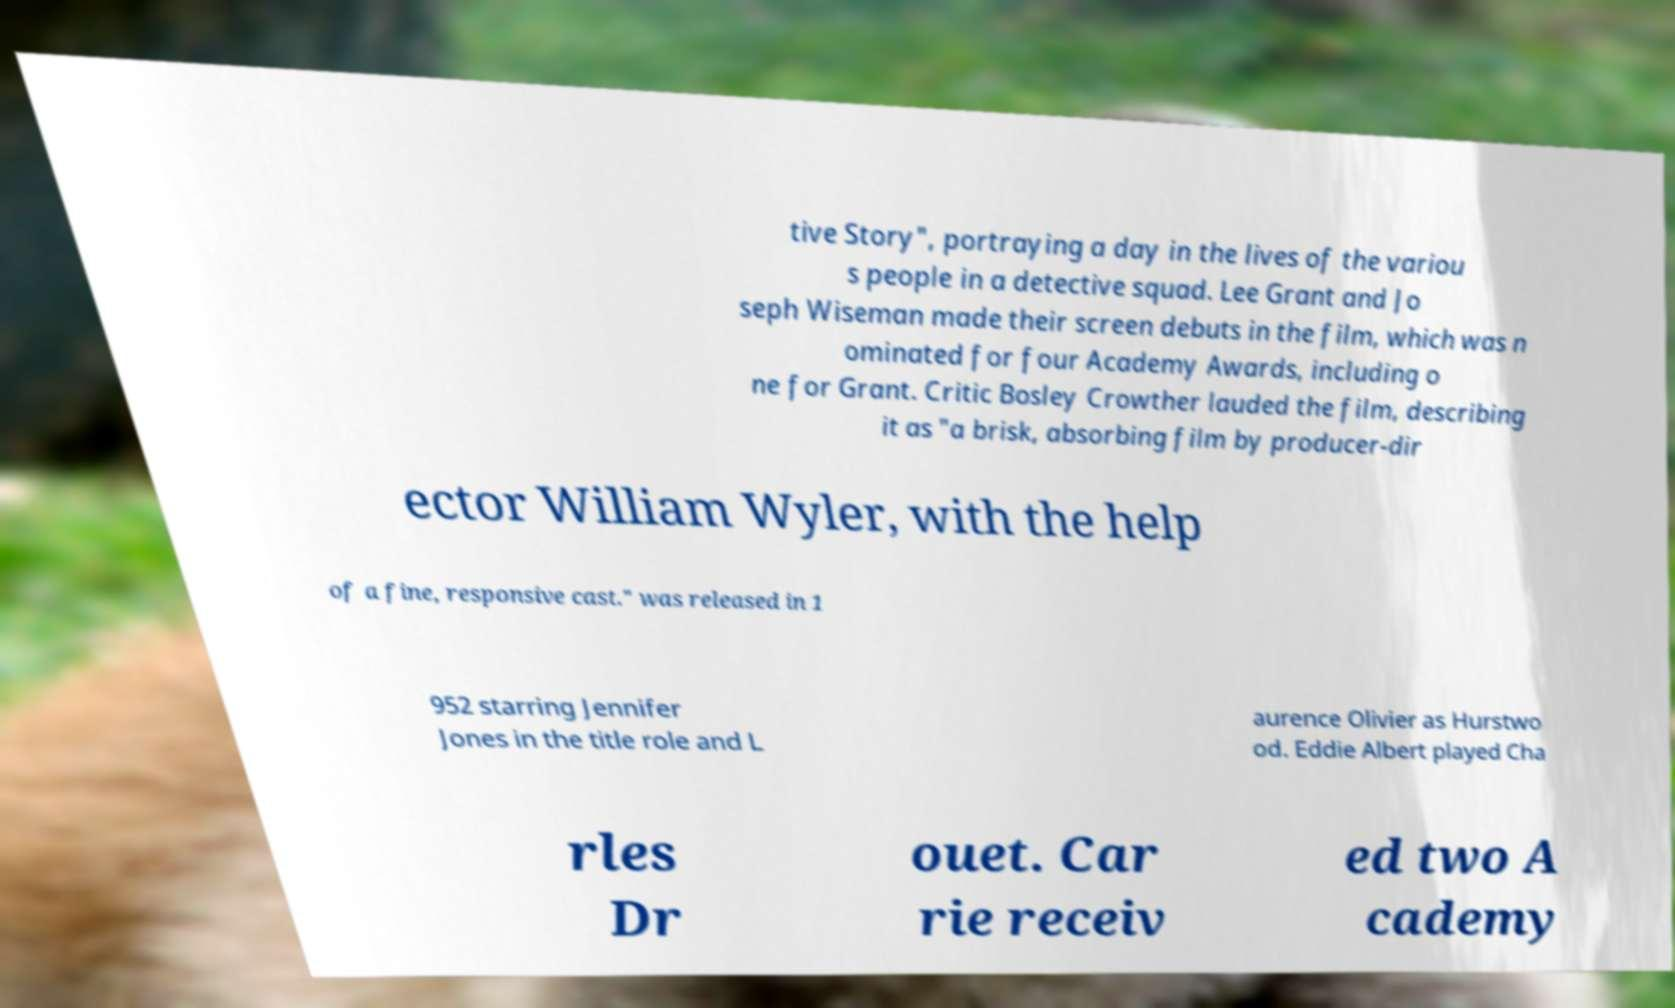Can you accurately transcribe the text from the provided image for me? tive Story", portraying a day in the lives of the variou s people in a detective squad. Lee Grant and Jo seph Wiseman made their screen debuts in the film, which was n ominated for four Academy Awards, including o ne for Grant. Critic Bosley Crowther lauded the film, describing it as "a brisk, absorbing film by producer-dir ector William Wyler, with the help of a fine, responsive cast." was released in 1 952 starring Jennifer Jones in the title role and L aurence Olivier as Hurstwo od. Eddie Albert played Cha rles Dr ouet. Car rie receiv ed two A cademy 